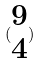<formula> <loc_0><loc_0><loc_500><loc_500>( \begin{matrix} 9 \\ 4 \end{matrix} )</formula> 